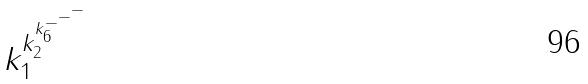Convert formula to latex. <formula><loc_0><loc_0><loc_500><loc_500>k _ { 1 } ^ { k _ { 2 } ^ { k _ { 6 } ^ { - ^ { - ^ { - } } } } }</formula> 